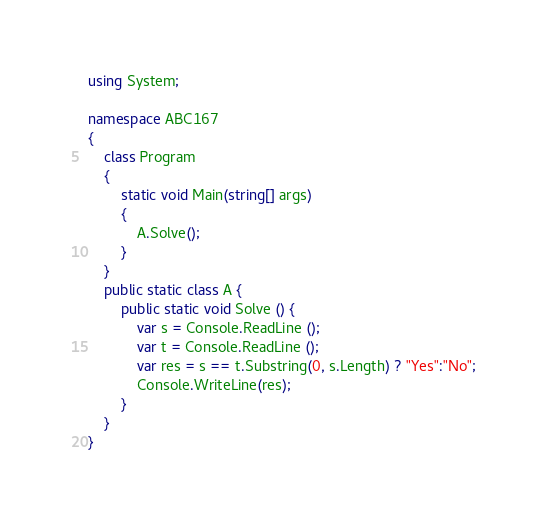<code> <loc_0><loc_0><loc_500><loc_500><_C#_>using System;

namespace ABC167
{
    class Program
    {
        static void Main(string[] args)
        {
            A.Solve();
        }
    }
    public static class A {
        public static void Solve () {
            var s = Console.ReadLine ();
            var t = Console.ReadLine ();
            var res = s == t.Substring(0, s.Length) ? "Yes":"No";
            Console.WriteLine(res);
        }
    }
}
</code> 